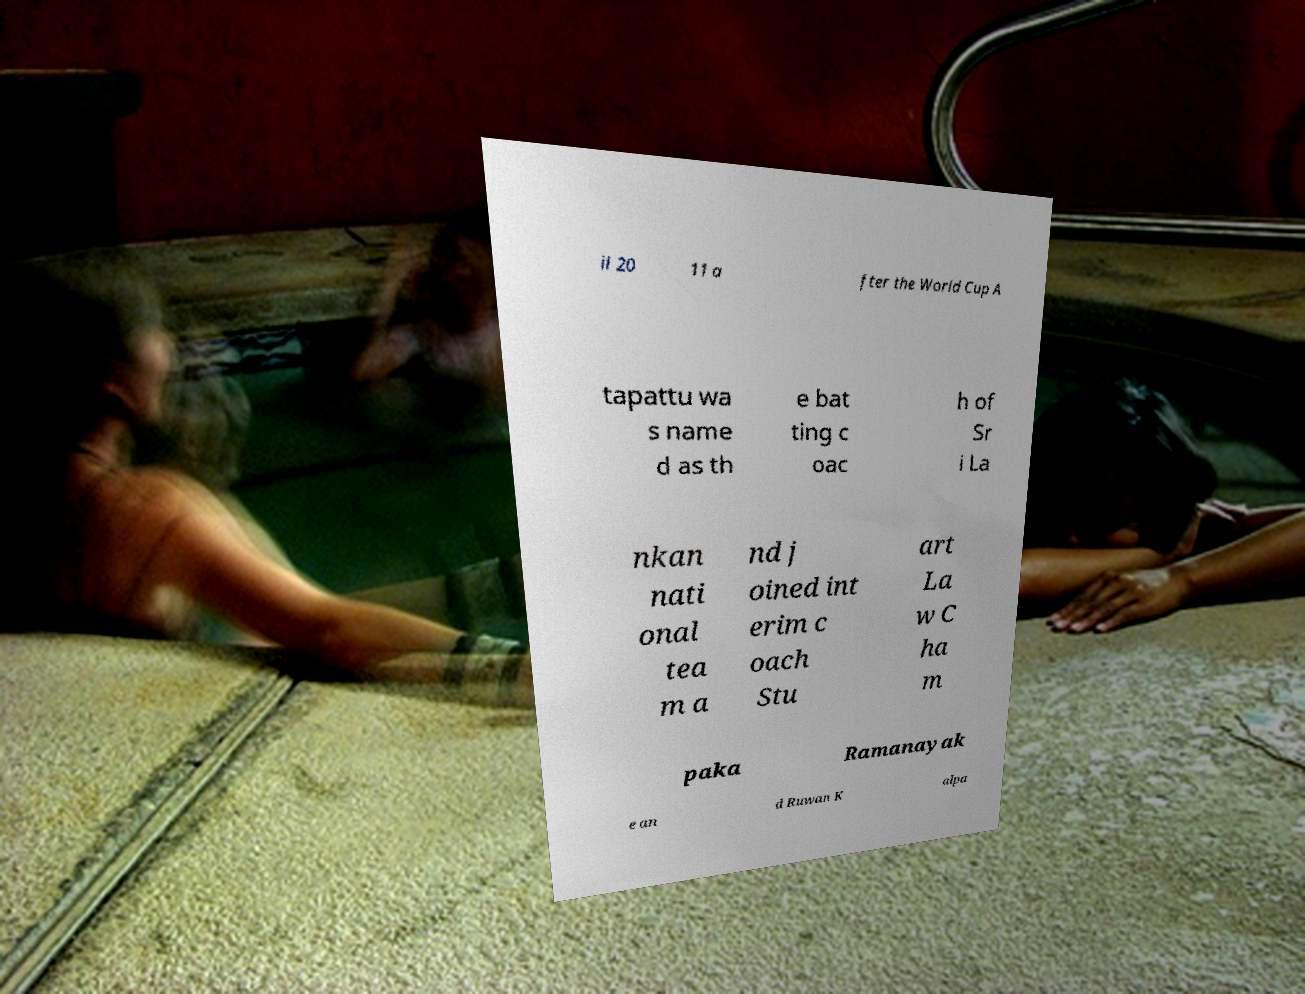For documentation purposes, I need the text within this image transcribed. Could you provide that? il 20 11 a fter the World Cup A tapattu wa s name d as th e bat ting c oac h of Sr i La nkan nati onal tea m a nd j oined int erim c oach Stu art La w C ha m paka Ramanayak e an d Ruwan K alpa 